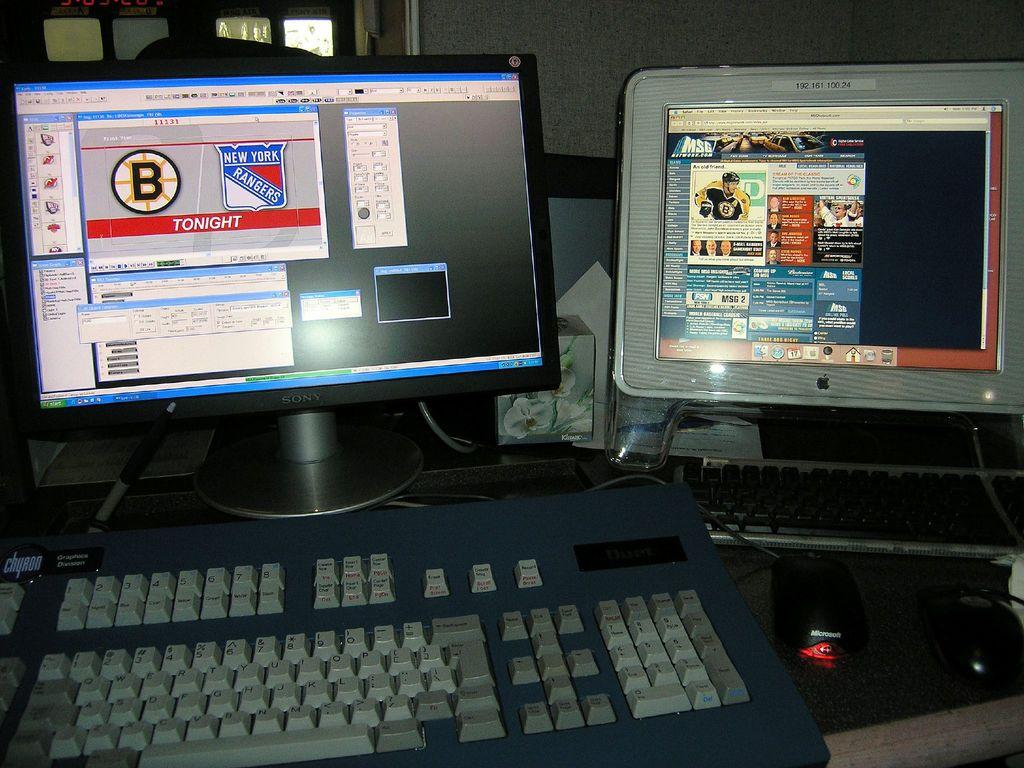<image>
Give a short and clear explanation of the subsequent image. A computer monitor displays information related to the New York Rangers. 